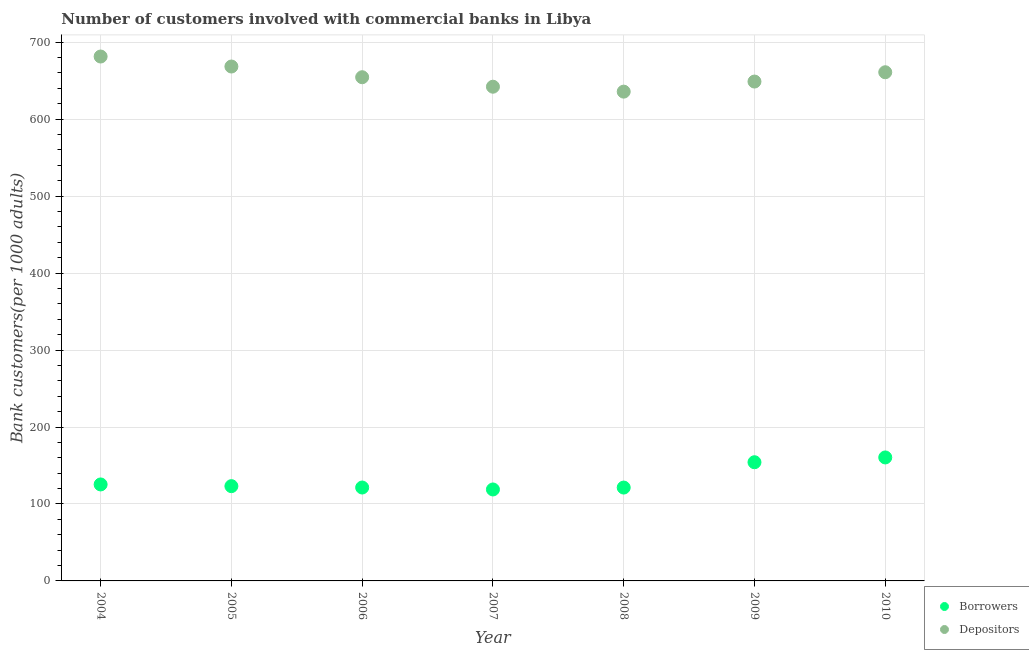How many different coloured dotlines are there?
Ensure brevity in your answer.  2. Is the number of dotlines equal to the number of legend labels?
Provide a succinct answer. Yes. What is the number of depositors in 2010?
Your answer should be very brief. 660.95. Across all years, what is the maximum number of borrowers?
Make the answer very short. 160.45. Across all years, what is the minimum number of depositors?
Ensure brevity in your answer.  635.76. In which year was the number of depositors maximum?
Your response must be concise. 2004. In which year was the number of borrowers minimum?
Ensure brevity in your answer.  2007. What is the total number of depositors in the graph?
Your response must be concise. 4592.01. What is the difference between the number of borrowers in 2005 and that in 2007?
Offer a terse response. 4.32. What is the difference between the number of borrowers in 2010 and the number of depositors in 2008?
Offer a terse response. -475.31. What is the average number of depositors per year?
Give a very brief answer. 656. In the year 2010, what is the difference between the number of borrowers and number of depositors?
Give a very brief answer. -500.51. In how many years, is the number of borrowers greater than 40?
Offer a terse response. 7. What is the ratio of the number of borrowers in 2005 to that in 2009?
Ensure brevity in your answer.  0.8. What is the difference between the highest and the second highest number of depositors?
Your answer should be very brief. 12.99. What is the difference between the highest and the lowest number of borrowers?
Your answer should be compact. 41.61. In how many years, is the number of depositors greater than the average number of depositors taken over all years?
Your answer should be very brief. 3. Is the sum of the number of borrowers in 2008 and 2009 greater than the maximum number of depositors across all years?
Offer a very short reply. No. Is the number of borrowers strictly less than the number of depositors over the years?
Offer a very short reply. Yes. How many years are there in the graph?
Offer a terse response. 7. Are the values on the major ticks of Y-axis written in scientific E-notation?
Ensure brevity in your answer.  No. Does the graph contain grids?
Offer a very short reply. Yes. Where does the legend appear in the graph?
Provide a succinct answer. Bottom right. How are the legend labels stacked?
Your response must be concise. Vertical. What is the title of the graph?
Give a very brief answer. Number of customers involved with commercial banks in Libya. Does "From Government" appear as one of the legend labels in the graph?
Keep it short and to the point. No. What is the label or title of the X-axis?
Keep it short and to the point. Year. What is the label or title of the Y-axis?
Provide a short and direct response. Bank customers(per 1000 adults). What is the Bank customers(per 1000 adults) in Borrowers in 2004?
Ensure brevity in your answer.  125.36. What is the Bank customers(per 1000 adults) of Depositors in 2004?
Your answer should be compact. 681.39. What is the Bank customers(per 1000 adults) in Borrowers in 2005?
Offer a very short reply. 123.15. What is the Bank customers(per 1000 adults) of Depositors in 2005?
Provide a succinct answer. 668.4. What is the Bank customers(per 1000 adults) of Borrowers in 2006?
Offer a very short reply. 121.36. What is the Bank customers(per 1000 adults) in Depositors in 2006?
Offer a terse response. 654.49. What is the Bank customers(per 1000 adults) in Borrowers in 2007?
Give a very brief answer. 118.83. What is the Bank customers(per 1000 adults) of Depositors in 2007?
Your answer should be compact. 642.16. What is the Bank customers(per 1000 adults) in Borrowers in 2008?
Provide a short and direct response. 121.31. What is the Bank customers(per 1000 adults) in Depositors in 2008?
Keep it short and to the point. 635.76. What is the Bank customers(per 1000 adults) of Borrowers in 2009?
Ensure brevity in your answer.  154.22. What is the Bank customers(per 1000 adults) of Depositors in 2009?
Keep it short and to the point. 648.86. What is the Bank customers(per 1000 adults) of Borrowers in 2010?
Provide a short and direct response. 160.45. What is the Bank customers(per 1000 adults) of Depositors in 2010?
Give a very brief answer. 660.95. Across all years, what is the maximum Bank customers(per 1000 adults) of Borrowers?
Offer a terse response. 160.45. Across all years, what is the maximum Bank customers(per 1000 adults) in Depositors?
Your answer should be compact. 681.39. Across all years, what is the minimum Bank customers(per 1000 adults) in Borrowers?
Offer a very short reply. 118.83. Across all years, what is the minimum Bank customers(per 1000 adults) in Depositors?
Your answer should be compact. 635.76. What is the total Bank customers(per 1000 adults) in Borrowers in the graph?
Your answer should be compact. 924.68. What is the total Bank customers(per 1000 adults) in Depositors in the graph?
Keep it short and to the point. 4592.01. What is the difference between the Bank customers(per 1000 adults) of Borrowers in 2004 and that in 2005?
Provide a succinct answer. 2.21. What is the difference between the Bank customers(per 1000 adults) in Depositors in 2004 and that in 2005?
Make the answer very short. 12.99. What is the difference between the Bank customers(per 1000 adults) of Borrowers in 2004 and that in 2006?
Your response must be concise. 4. What is the difference between the Bank customers(per 1000 adults) of Depositors in 2004 and that in 2006?
Your response must be concise. 26.9. What is the difference between the Bank customers(per 1000 adults) of Borrowers in 2004 and that in 2007?
Provide a short and direct response. 6.52. What is the difference between the Bank customers(per 1000 adults) of Depositors in 2004 and that in 2007?
Provide a succinct answer. 39.23. What is the difference between the Bank customers(per 1000 adults) of Borrowers in 2004 and that in 2008?
Offer a terse response. 4.05. What is the difference between the Bank customers(per 1000 adults) of Depositors in 2004 and that in 2008?
Your response must be concise. 45.63. What is the difference between the Bank customers(per 1000 adults) in Borrowers in 2004 and that in 2009?
Your response must be concise. -28.86. What is the difference between the Bank customers(per 1000 adults) of Depositors in 2004 and that in 2009?
Provide a short and direct response. 32.53. What is the difference between the Bank customers(per 1000 adults) of Borrowers in 2004 and that in 2010?
Provide a succinct answer. -35.09. What is the difference between the Bank customers(per 1000 adults) in Depositors in 2004 and that in 2010?
Offer a terse response. 20.43. What is the difference between the Bank customers(per 1000 adults) of Borrowers in 2005 and that in 2006?
Ensure brevity in your answer.  1.79. What is the difference between the Bank customers(per 1000 adults) of Depositors in 2005 and that in 2006?
Your answer should be compact. 13.9. What is the difference between the Bank customers(per 1000 adults) of Borrowers in 2005 and that in 2007?
Ensure brevity in your answer.  4.32. What is the difference between the Bank customers(per 1000 adults) of Depositors in 2005 and that in 2007?
Provide a short and direct response. 26.24. What is the difference between the Bank customers(per 1000 adults) in Borrowers in 2005 and that in 2008?
Your response must be concise. 1.84. What is the difference between the Bank customers(per 1000 adults) of Depositors in 2005 and that in 2008?
Ensure brevity in your answer.  32.63. What is the difference between the Bank customers(per 1000 adults) in Borrowers in 2005 and that in 2009?
Offer a very short reply. -31.07. What is the difference between the Bank customers(per 1000 adults) in Depositors in 2005 and that in 2009?
Provide a short and direct response. 19.53. What is the difference between the Bank customers(per 1000 adults) in Borrowers in 2005 and that in 2010?
Your response must be concise. -37.3. What is the difference between the Bank customers(per 1000 adults) in Depositors in 2005 and that in 2010?
Provide a succinct answer. 7.44. What is the difference between the Bank customers(per 1000 adults) in Borrowers in 2006 and that in 2007?
Provide a succinct answer. 2.53. What is the difference between the Bank customers(per 1000 adults) in Depositors in 2006 and that in 2007?
Make the answer very short. 12.33. What is the difference between the Bank customers(per 1000 adults) of Borrowers in 2006 and that in 2008?
Offer a very short reply. 0.06. What is the difference between the Bank customers(per 1000 adults) of Depositors in 2006 and that in 2008?
Your response must be concise. 18.73. What is the difference between the Bank customers(per 1000 adults) in Borrowers in 2006 and that in 2009?
Your response must be concise. -32.86. What is the difference between the Bank customers(per 1000 adults) of Depositors in 2006 and that in 2009?
Offer a very short reply. 5.63. What is the difference between the Bank customers(per 1000 adults) in Borrowers in 2006 and that in 2010?
Ensure brevity in your answer.  -39.08. What is the difference between the Bank customers(per 1000 adults) in Depositors in 2006 and that in 2010?
Make the answer very short. -6.46. What is the difference between the Bank customers(per 1000 adults) of Borrowers in 2007 and that in 2008?
Your response must be concise. -2.47. What is the difference between the Bank customers(per 1000 adults) of Depositors in 2007 and that in 2008?
Provide a short and direct response. 6.4. What is the difference between the Bank customers(per 1000 adults) in Borrowers in 2007 and that in 2009?
Provide a short and direct response. -35.39. What is the difference between the Bank customers(per 1000 adults) in Depositors in 2007 and that in 2009?
Your response must be concise. -6.7. What is the difference between the Bank customers(per 1000 adults) of Borrowers in 2007 and that in 2010?
Offer a very short reply. -41.61. What is the difference between the Bank customers(per 1000 adults) in Depositors in 2007 and that in 2010?
Ensure brevity in your answer.  -18.8. What is the difference between the Bank customers(per 1000 adults) of Borrowers in 2008 and that in 2009?
Provide a short and direct response. -32.92. What is the difference between the Bank customers(per 1000 adults) of Depositors in 2008 and that in 2009?
Give a very brief answer. -13.1. What is the difference between the Bank customers(per 1000 adults) of Borrowers in 2008 and that in 2010?
Provide a succinct answer. -39.14. What is the difference between the Bank customers(per 1000 adults) in Depositors in 2008 and that in 2010?
Offer a terse response. -25.19. What is the difference between the Bank customers(per 1000 adults) in Borrowers in 2009 and that in 2010?
Give a very brief answer. -6.22. What is the difference between the Bank customers(per 1000 adults) in Depositors in 2009 and that in 2010?
Make the answer very short. -12.09. What is the difference between the Bank customers(per 1000 adults) in Borrowers in 2004 and the Bank customers(per 1000 adults) in Depositors in 2005?
Provide a succinct answer. -543.04. What is the difference between the Bank customers(per 1000 adults) in Borrowers in 2004 and the Bank customers(per 1000 adults) in Depositors in 2006?
Your response must be concise. -529.13. What is the difference between the Bank customers(per 1000 adults) of Borrowers in 2004 and the Bank customers(per 1000 adults) of Depositors in 2007?
Provide a succinct answer. -516.8. What is the difference between the Bank customers(per 1000 adults) of Borrowers in 2004 and the Bank customers(per 1000 adults) of Depositors in 2008?
Your answer should be compact. -510.4. What is the difference between the Bank customers(per 1000 adults) in Borrowers in 2004 and the Bank customers(per 1000 adults) in Depositors in 2009?
Your answer should be very brief. -523.5. What is the difference between the Bank customers(per 1000 adults) in Borrowers in 2004 and the Bank customers(per 1000 adults) in Depositors in 2010?
Provide a short and direct response. -535.6. What is the difference between the Bank customers(per 1000 adults) of Borrowers in 2005 and the Bank customers(per 1000 adults) of Depositors in 2006?
Provide a short and direct response. -531.34. What is the difference between the Bank customers(per 1000 adults) in Borrowers in 2005 and the Bank customers(per 1000 adults) in Depositors in 2007?
Make the answer very short. -519.01. What is the difference between the Bank customers(per 1000 adults) in Borrowers in 2005 and the Bank customers(per 1000 adults) in Depositors in 2008?
Offer a terse response. -512.61. What is the difference between the Bank customers(per 1000 adults) of Borrowers in 2005 and the Bank customers(per 1000 adults) of Depositors in 2009?
Your response must be concise. -525.71. What is the difference between the Bank customers(per 1000 adults) of Borrowers in 2005 and the Bank customers(per 1000 adults) of Depositors in 2010?
Offer a very short reply. -537.8. What is the difference between the Bank customers(per 1000 adults) of Borrowers in 2006 and the Bank customers(per 1000 adults) of Depositors in 2007?
Provide a short and direct response. -520.79. What is the difference between the Bank customers(per 1000 adults) in Borrowers in 2006 and the Bank customers(per 1000 adults) in Depositors in 2008?
Provide a succinct answer. -514.4. What is the difference between the Bank customers(per 1000 adults) in Borrowers in 2006 and the Bank customers(per 1000 adults) in Depositors in 2009?
Provide a short and direct response. -527.5. What is the difference between the Bank customers(per 1000 adults) in Borrowers in 2006 and the Bank customers(per 1000 adults) in Depositors in 2010?
Ensure brevity in your answer.  -539.59. What is the difference between the Bank customers(per 1000 adults) of Borrowers in 2007 and the Bank customers(per 1000 adults) of Depositors in 2008?
Provide a succinct answer. -516.93. What is the difference between the Bank customers(per 1000 adults) in Borrowers in 2007 and the Bank customers(per 1000 adults) in Depositors in 2009?
Your answer should be very brief. -530.03. What is the difference between the Bank customers(per 1000 adults) of Borrowers in 2007 and the Bank customers(per 1000 adults) of Depositors in 2010?
Offer a very short reply. -542.12. What is the difference between the Bank customers(per 1000 adults) of Borrowers in 2008 and the Bank customers(per 1000 adults) of Depositors in 2009?
Offer a terse response. -527.55. What is the difference between the Bank customers(per 1000 adults) in Borrowers in 2008 and the Bank customers(per 1000 adults) in Depositors in 2010?
Ensure brevity in your answer.  -539.65. What is the difference between the Bank customers(per 1000 adults) of Borrowers in 2009 and the Bank customers(per 1000 adults) of Depositors in 2010?
Provide a short and direct response. -506.73. What is the average Bank customers(per 1000 adults) in Borrowers per year?
Your answer should be compact. 132.1. What is the average Bank customers(per 1000 adults) of Depositors per year?
Offer a terse response. 656. In the year 2004, what is the difference between the Bank customers(per 1000 adults) in Borrowers and Bank customers(per 1000 adults) in Depositors?
Ensure brevity in your answer.  -556.03. In the year 2005, what is the difference between the Bank customers(per 1000 adults) in Borrowers and Bank customers(per 1000 adults) in Depositors?
Make the answer very short. -545.24. In the year 2006, what is the difference between the Bank customers(per 1000 adults) of Borrowers and Bank customers(per 1000 adults) of Depositors?
Your response must be concise. -533.13. In the year 2007, what is the difference between the Bank customers(per 1000 adults) in Borrowers and Bank customers(per 1000 adults) in Depositors?
Offer a very short reply. -523.32. In the year 2008, what is the difference between the Bank customers(per 1000 adults) of Borrowers and Bank customers(per 1000 adults) of Depositors?
Make the answer very short. -514.45. In the year 2009, what is the difference between the Bank customers(per 1000 adults) of Borrowers and Bank customers(per 1000 adults) of Depositors?
Your response must be concise. -494.64. In the year 2010, what is the difference between the Bank customers(per 1000 adults) of Borrowers and Bank customers(per 1000 adults) of Depositors?
Your answer should be compact. -500.51. What is the ratio of the Bank customers(per 1000 adults) in Borrowers in 2004 to that in 2005?
Provide a succinct answer. 1.02. What is the ratio of the Bank customers(per 1000 adults) of Depositors in 2004 to that in 2005?
Provide a short and direct response. 1.02. What is the ratio of the Bank customers(per 1000 adults) in Borrowers in 2004 to that in 2006?
Offer a terse response. 1.03. What is the ratio of the Bank customers(per 1000 adults) of Depositors in 2004 to that in 2006?
Ensure brevity in your answer.  1.04. What is the ratio of the Bank customers(per 1000 adults) in Borrowers in 2004 to that in 2007?
Keep it short and to the point. 1.05. What is the ratio of the Bank customers(per 1000 adults) in Depositors in 2004 to that in 2007?
Give a very brief answer. 1.06. What is the ratio of the Bank customers(per 1000 adults) of Borrowers in 2004 to that in 2008?
Keep it short and to the point. 1.03. What is the ratio of the Bank customers(per 1000 adults) in Depositors in 2004 to that in 2008?
Your answer should be very brief. 1.07. What is the ratio of the Bank customers(per 1000 adults) in Borrowers in 2004 to that in 2009?
Give a very brief answer. 0.81. What is the ratio of the Bank customers(per 1000 adults) of Depositors in 2004 to that in 2009?
Keep it short and to the point. 1.05. What is the ratio of the Bank customers(per 1000 adults) in Borrowers in 2004 to that in 2010?
Give a very brief answer. 0.78. What is the ratio of the Bank customers(per 1000 adults) of Depositors in 2004 to that in 2010?
Keep it short and to the point. 1.03. What is the ratio of the Bank customers(per 1000 adults) in Borrowers in 2005 to that in 2006?
Your response must be concise. 1.01. What is the ratio of the Bank customers(per 1000 adults) of Depositors in 2005 to that in 2006?
Your answer should be compact. 1.02. What is the ratio of the Bank customers(per 1000 adults) in Borrowers in 2005 to that in 2007?
Keep it short and to the point. 1.04. What is the ratio of the Bank customers(per 1000 adults) in Depositors in 2005 to that in 2007?
Keep it short and to the point. 1.04. What is the ratio of the Bank customers(per 1000 adults) of Borrowers in 2005 to that in 2008?
Provide a short and direct response. 1.02. What is the ratio of the Bank customers(per 1000 adults) of Depositors in 2005 to that in 2008?
Give a very brief answer. 1.05. What is the ratio of the Bank customers(per 1000 adults) of Borrowers in 2005 to that in 2009?
Your response must be concise. 0.8. What is the ratio of the Bank customers(per 1000 adults) of Depositors in 2005 to that in 2009?
Your answer should be compact. 1.03. What is the ratio of the Bank customers(per 1000 adults) of Borrowers in 2005 to that in 2010?
Provide a short and direct response. 0.77. What is the ratio of the Bank customers(per 1000 adults) of Depositors in 2005 to that in 2010?
Provide a succinct answer. 1.01. What is the ratio of the Bank customers(per 1000 adults) of Borrowers in 2006 to that in 2007?
Make the answer very short. 1.02. What is the ratio of the Bank customers(per 1000 adults) of Depositors in 2006 to that in 2007?
Your answer should be compact. 1.02. What is the ratio of the Bank customers(per 1000 adults) of Borrowers in 2006 to that in 2008?
Provide a succinct answer. 1. What is the ratio of the Bank customers(per 1000 adults) of Depositors in 2006 to that in 2008?
Make the answer very short. 1.03. What is the ratio of the Bank customers(per 1000 adults) in Borrowers in 2006 to that in 2009?
Make the answer very short. 0.79. What is the ratio of the Bank customers(per 1000 adults) in Depositors in 2006 to that in 2009?
Make the answer very short. 1.01. What is the ratio of the Bank customers(per 1000 adults) of Borrowers in 2006 to that in 2010?
Your response must be concise. 0.76. What is the ratio of the Bank customers(per 1000 adults) in Depositors in 2006 to that in 2010?
Ensure brevity in your answer.  0.99. What is the ratio of the Bank customers(per 1000 adults) of Borrowers in 2007 to that in 2008?
Keep it short and to the point. 0.98. What is the ratio of the Bank customers(per 1000 adults) in Borrowers in 2007 to that in 2009?
Give a very brief answer. 0.77. What is the ratio of the Bank customers(per 1000 adults) in Borrowers in 2007 to that in 2010?
Your response must be concise. 0.74. What is the ratio of the Bank customers(per 1000 adults) in Depositors in 2007 to that in 2010?
Keep it short and to the point. 0.97. What is the ratio of the Bank customers(per 1000 adults) of Borrowers in 2008 to that in 2009?
Provide a succinct answer. 0.79. What is the ratio of the Bank customers(per 1000 adults) of Depositors in 2008 to that in 2009?
Keep it short and to the point. 0.98. What is the ratio of the Bank customers(per 1000 adults) in Borrowers in 2008 to that in 2010?
Offer a very short reply. 0.76. What is the ratio of the Bank customers(per 1000 adults) of Depositors in 2008 to that in 2010?
Provide a short and direct response. 0.96. What is the ratio of the Bank customers(per 1000 adults) in Borrowers in 2009 to that in 2010?
Ensure brevity in your answer.  0.96. What is the ratio of the Bank customers(per 1000 adults) of Depositors in 2009 to that in 2010?
Your answer should be compact. 0.98. What is the difference between the highest and the second highest Bank customers(per 1000 adults) in Borrowers?
Give a very brief answer. 6.22. What is the difference between the highest and the second highest Bank customers(per 1000 adults) in Depositors?
Your response must be concise. 12.99. What is the difference between the highest and the lowest Bank customers(per 1000 adults) in Borrowers?
Keep it short and to the point. 41.61. What is the difference between the highest and the lowest Bank customers(per 1000 adults) in Depositors?
Ensure brevity in your answer.  45.63. 